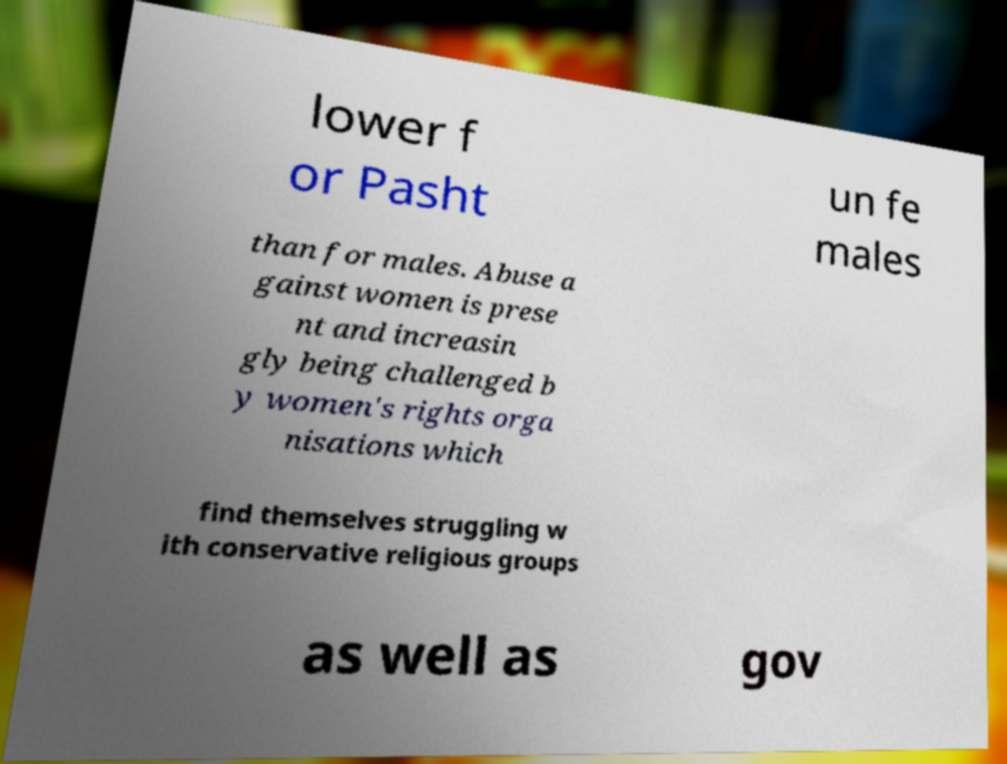There's text embedded in this image that I need extracted. Can you transcribe it verbatim? lower f or Pasht un fe males than for males. Abuse a gainst women is prese nt and increasin gly being challenged b y women's rights orga nisations which find themselves struggling w ith conservative religious groups as well as gov 